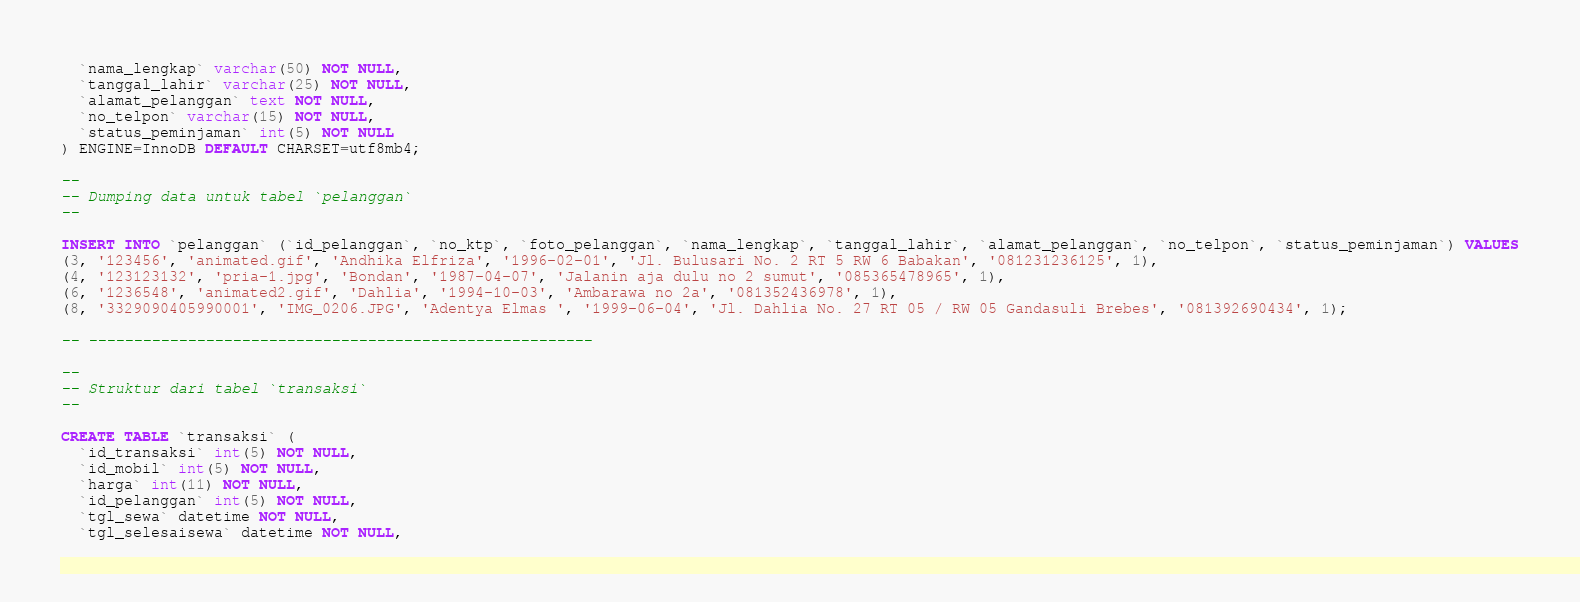<code> <loc_0><loc_0><loc_500><loc_500><_SQL_>  `nama_lengkap` varchar(50) NOT NULL,
  `tanggal_lahir` varchar(25) NOT NULL,
  `alamat_pelanggan` text NOT NULL,
  `no_telpon` varchar(15) NOT NULL,
  `status_peminjaman` int(5) NOT NULL
) ENGINE=InnoDB DEFAULT CHARSET=utf8mb4;

--
-- Dumping data untuk tabel `pelanggan`
--

INSERT INTO `pelanggan` (`id_pelanggan`, `no_ktp`, `foto_pelanggan`, `nama_lengkap`, `tanggal_lahir`, `alamat_pelanggan`, `no_telpon`, `status_peminjaman`) VALUES
(3, '123456', 'animated.gif', 'Andhika Elfriza', '1996-02-01', 'Jl. Bulusari No. 2 RT 5 RW 6 Babakan', '081231236125', 1),
(4, '123123132', 'pria-1.jpg', 'Bondan', '1987-04-07', 'Jalanin aja dulu no 2 sumut', '085365478965', 1),
(6, '1236548', 'animated2.gif', 'Dahlia', '1994-10-03', 'Ambarawa no 2a', '081352436978', 1),
(8, '3329090405990001', 'IMG_0206.JPG', 'Adentya Elmas ', '1999-06-04', 'Jl. Dahlia No. 27 RT 05 / RW 05 Gandasuli Brebes', '081392690434', 1);

-- --------------------------------------------------------

--
-- Struktur dari tabel `transaksi`
--

CREATE TABLE `transaksi` (
  `id_transaksi` int(5) NOT NULL,
  `id_mobil` int(5) NOT NULL,
  `harga` int(11) NOT NULL,
  `id_pelanggan` int(5) NOT NULL,
  `tgl_sewa` datetime NOT NULL,
  `tgl_selesaisewa` datetime NOT NULL,</code> 